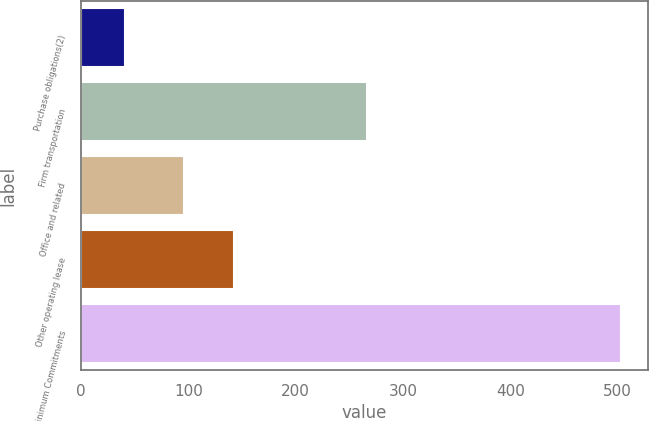Convert chart to OTSL. <chart><loc_0><loc_0><loc_500><loc_500><bar_chart><fcel>Purchase obligations(2)<fcel>Firm transportation<fcel>Office and related<fcel>Other operating lease<fcel>Total Net Minimum Commitments<nl><fcel>41<fcel>266<fcel>96<fcel>142.2<fcel>503<nl></chart> 